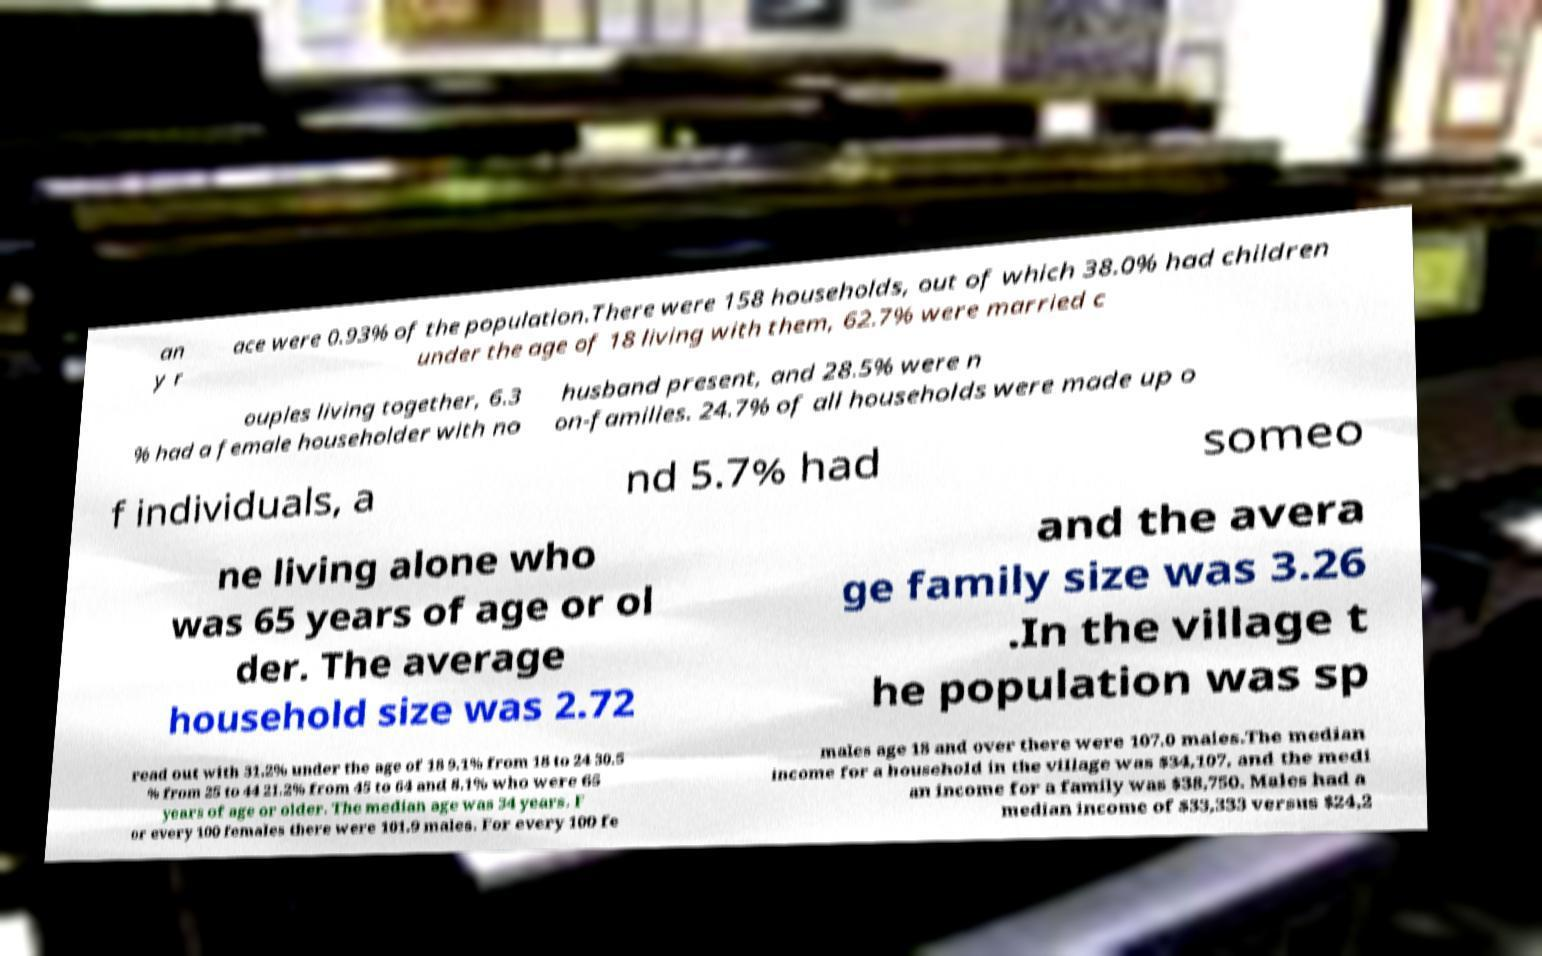Could you assist in decoding the text presented in this image and type it out clearly? an y r ace were 0.93% of the population.There were 158 households, out of which 38.0% had children under the age of 18 living with them, 62.7% were married c ouples living together, 6.3 % had a female householder with no husband present, and 28.5% were n on-families. 24.7% of all households were made up o f individuals, a nd 5.7% had someo ne living alone who was 65 years of age or ol der. The average household size was 2.72 and the avera ge family size was 3.26 .In the village t he population was sp read out with 31.2% under the age of 18 9.1% from 18 to 24 30.5 % from 25 to 44 21.2% from 45 to 64 and 8.1% who were 65 years of age or older. The median age was 34 years. F or every 100 females there were 101.9 males. For every 100 fe males age 18 and over there were 107.0 males.The median income for a household in the village was $34,107, and the medi an income for a family was $38,750. Males had a median income of $33,333 versus $24,2 